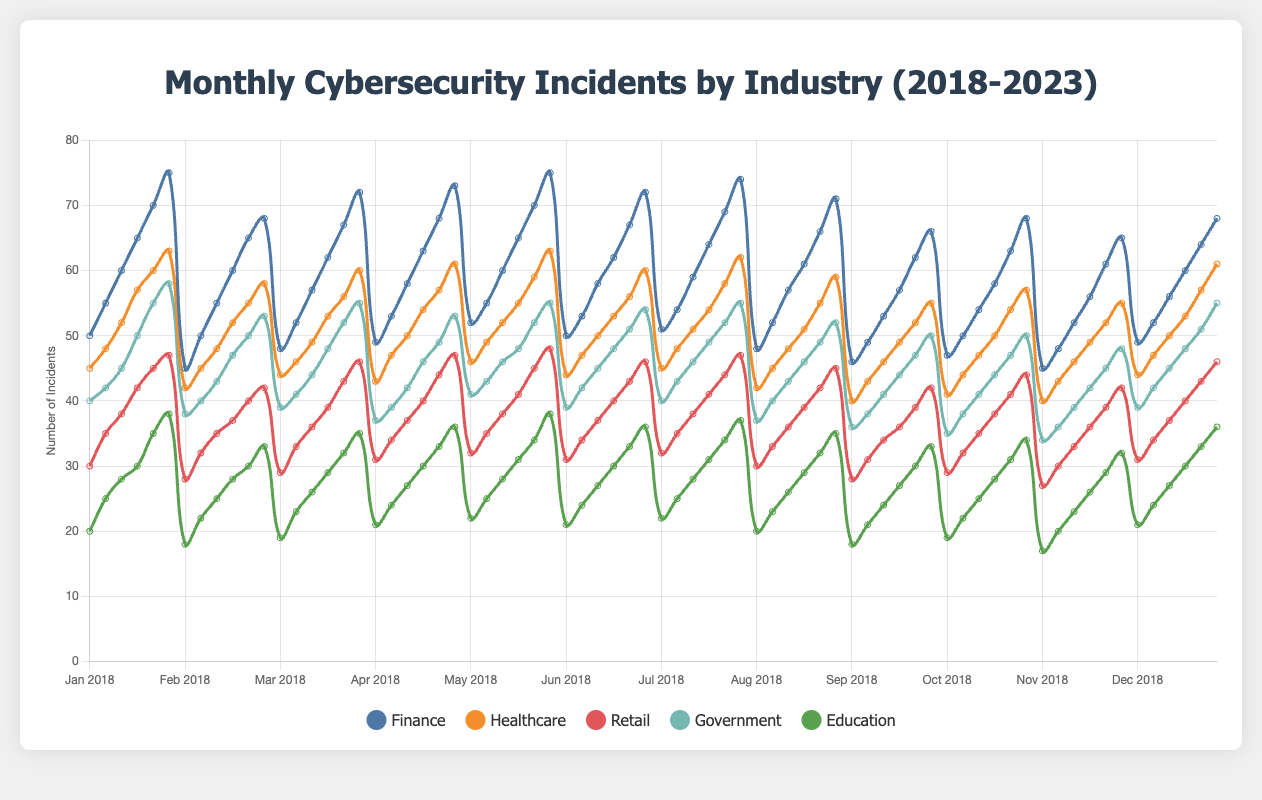Which industry reported the highest number of cybersecurity incidents in January 2023? The industries include Finance, Healthcare, Retail, Government, and Education. According to the figure, the Finance industry reported the most incidents in January 2023 with 75 incidents.
Answer: Finance What is the average number of incidents reported in Finance over the five years in January? For Finance, we take the incidents from January for each year: (50 + 55 + 60 + 65 + 70 + 75) and sum them up to get 375. Then we divide by the number of years, which is 6. The average is 375/6.
Answer: 62.5 Which months in 2023 have the highest and lowest number of incidents reported in Healthcare? Reviewing the chart for Healthcare in 2023 shows: Jan 63, Feb 58, Mar 60, Apr 61, May 63, Jun 60, Jul 62, Aug 59, Sep 55, Oct 57, Nov 55, Dec 61. January and May have the highest number (63), and September and November have the lowest number (55).
Answer: January/May (highest), September/November (lowest) How does the number of incidents in Retail in July 2023 compare to July 2021? In July, Retail incidents were 47 in 2023 and 41 in 2021. Comparing these values, 2023 has 6 more incidents than 2021.
Answer: 6 more in 2023 What is the total number of incidents reported by Government in March from 2018 to 2023? Summing Government incidents in March over the years: (39 + 41 + 44 + 48 + 52 + 55) equals 279.
Answer: 279 What trend is observed in the Education sector from 2018 to 2023? The line chart shows a consistent increase in incidents each year: 2018 to 2023 displaying a steady upward trend in reported incidents.
Answer: Increasing trend What is the difference in the number of incidents reported by Finance and Education in January 2023? In January 2023, Finance reported 75 incidents, while Education reported 38 incidents. The difference is calculated as 75 - 38.
Answer: 37 How did the number of cybersecurity incidents change for the Healthcare industry from January to December in 2023? Checking Healthcare from January (63) to December (61), the number of incidents slightly decreased by 2.
Answer: Decreased by 2 Which industry showed the least variation in incidents from month to month in 2023? Looking at the dataset, the Education sector had the smallest variation each month, ranging from 33 to 38 incidents, indicating the least fluctuation.
Answer: Education 